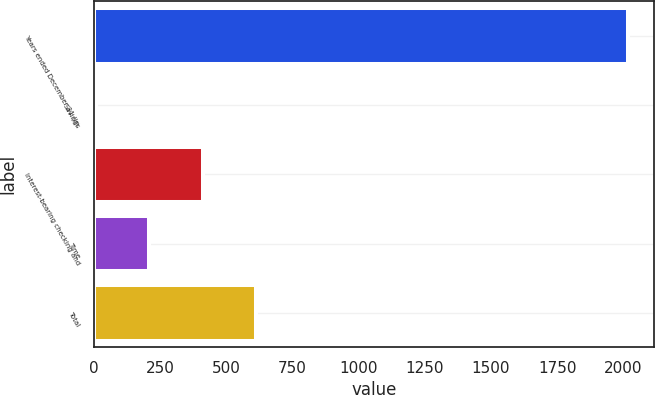Convert chart to OTSL. <chart><loc_0><loc_0><loc_500><loc_500><bar_chart><fcel>Years ended December 31 (in<fcel>Savings<fcel>Interest-bearing checking and<fcel>Time<fcel>Total<nl><fcel>2017<fcel>9.7<fcel>411.16<fcel>210.43<fcel>611.89<nl></chart> 